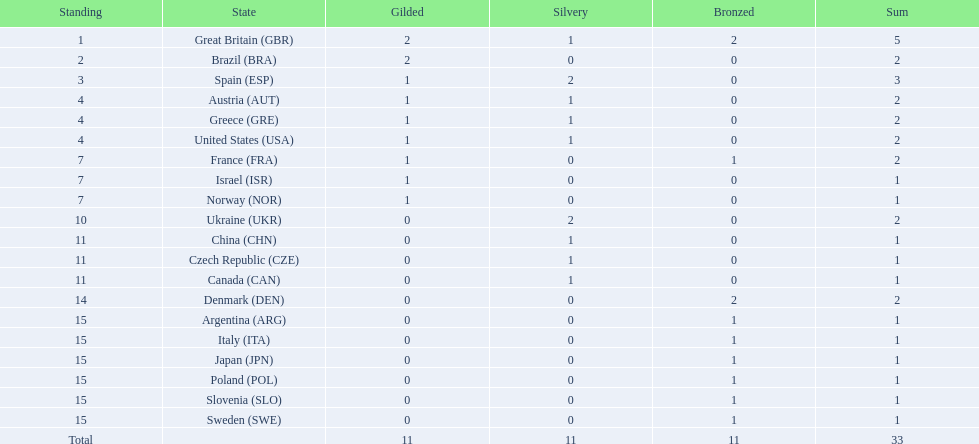How many gold medals did italy receive? 0. 